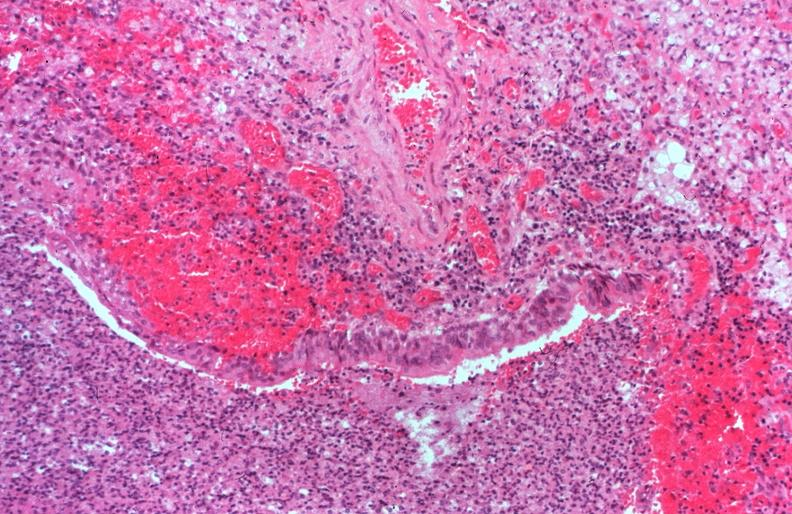what does this image show?
Answer the question using a single word or phrase. Lung 